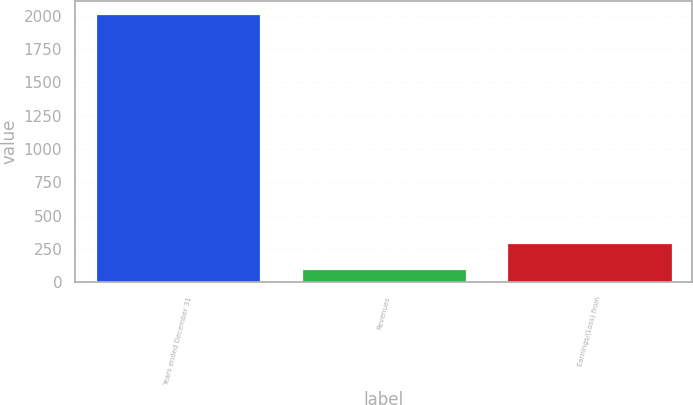<chart> <loc_0><loc_0><loc_500><loc_500><bar_chart><fcel>Years ended December 31<fcel>Revenues<fcel>Earnings/(Loss) from<nl><fcel>2013<fcel>102<fcel>293.1<nl></chart> 